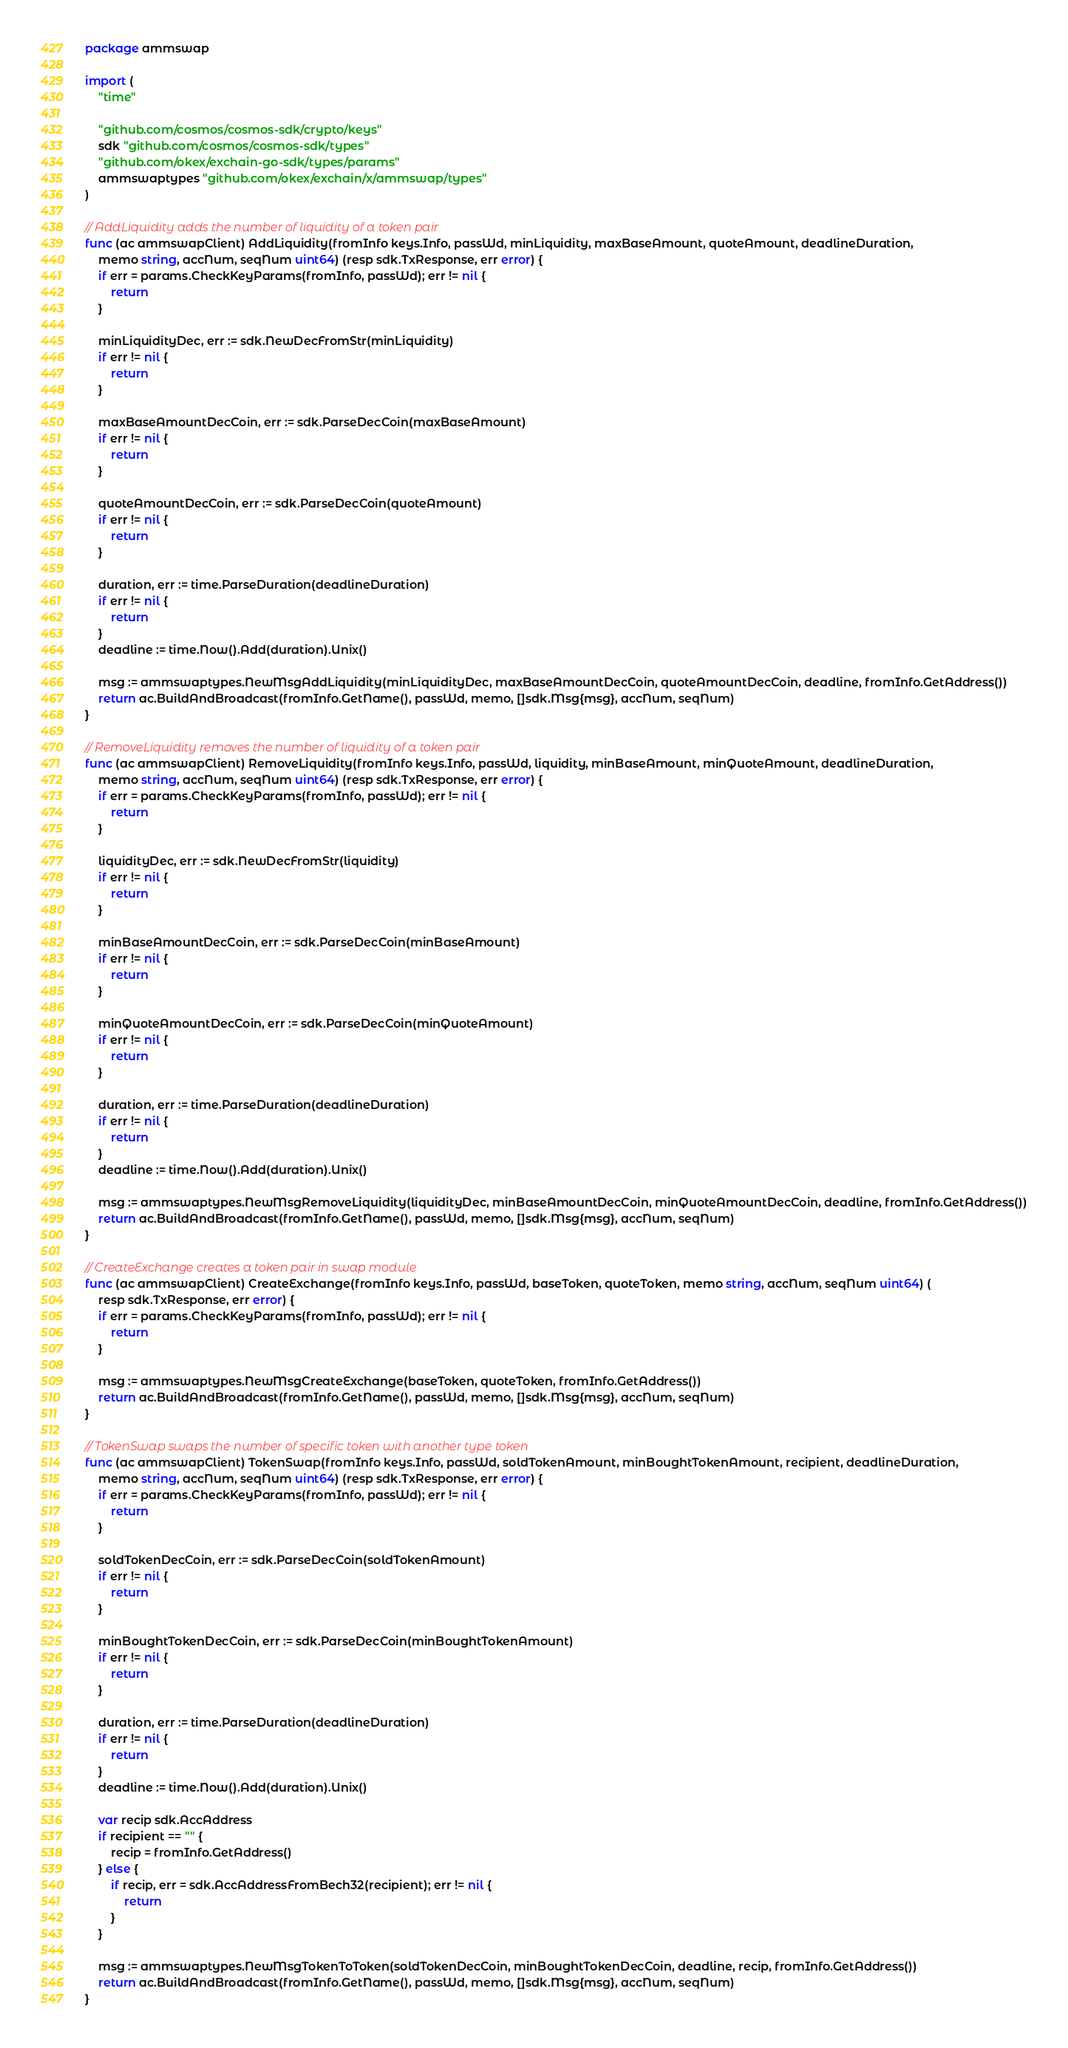<code> <loc_0><loc_0><loc_500><loc_500><_Go_>package ammswap

import (
	"time"

	"github.com/cosmos/cosmos-sdk/crypto/keys"
	sdk "github.com/cosmos/cosmos-sdk/types"
	"github.com/okex/exchain-go-sdk/types/params"
	ammswaptypes "github.com/okex/exchain/x/ammswap/types"
)

// AddLiquidity adds the number of liquidity of a token pair
func (ac ammswapClient) AddLiquidity(fromInfo keys.Info, passWd, minLiquidity, maxBaseAmount, quoteAmount, deadlineDuration,
	memo string, accNum, seqNum uint64) (resp sdk.TxResponse, err error) {
	if err = params.CheckKeyParams(fromInfo, passWd); err != nil {
		return
	}

	minLiquidityDec, err := sdk.NewDecFromStr(minLiquidity)
	if err != nil {
		return
	}

	maxBaseAmountDecCoin, err := sdk.ParseDecCoin(maxBaseAmount)
	if err != nil {
		return
	}

	quoteAmountDecCoin, err := sdk.ParseDecCoin(quoteAmount)
	if err != nil {
		return
	}

	duration, err := time.ParseDuration(deadlineDuration)
	if err != nil {
		return
	}
	deadline := time.Now().Add(duration).Unix()

	msg := ammswaptypes.NewMsgAddLiquidity(minLiquidityDec, maxBaseAmountDecCoin, quoteAmountDecCoin, deadline, fromInfo.GetAddress())
	return ac.BuildAndBroadcast(fromInfo.GetName(), passWd, memo, []sdk.Msg{msg}, accNum, seqNum)
}

// RemoveLiquidity removes the number of liquidity of a token pair
func (ac ammswapClient) RemoveLiquidity(fromInfo keys.Info, passWd, liquidity, minBaseAmount, minQuoteAmount, deadlineDuration,
	memo string, accNum, seqNum uint64) (resp sdk.TxResponse, err error) {
	if err = params.CheckKeyParams(fromInfo, passWd); err != nil {
		return
	}

	liquidityDec, err := sdk.NewDecFromStr(liquidity)
	if err != nil {
		return
	}

	minBaseAmountDecCoin, err := sdk.ParseDecCoin(minBaseAmount)
	if err != nil {
		return
	}

	minQuoteAmountDecCoin, err := sdk.ParseDecCoin(minQuoteAmount)
	if err != nil {
		return
	}

	duration, err := time.ParseDuration(deadlineDuration)
	if err != nil {
		return
	}
	deadline := time.Now().Add(duration).Unix()

	msg := ammswaptypes.NewMsgRemoveLiquidity(liquidityDec, minBaseAmountDecCoin, minQuoteAmountDecCoin, deadline, fromInfo.GetAddress())
	return ac.BuildAndBroadcast(fromInfo.GetName(), passWd, memo, []sdk.Msg{msg}, accNum, seqNum)
}

// CreateExchange creates a token pair in swap module
func (ac ammswapClient) CreateExchange(fromInfo keys.Info, passWd, baseToken, quoteToken, memo string, accNum, seqNum uint64) (
	resp sdk.TxResponse, err error) {
	if err = params.CheckKeyParams(fromInfo, passWd); err != nil {
		return
	}

	msg := ammswaptypes.NewMsgCreateExchange(baseToken, quoteToken, fromInfo.GetAddress())
	return ac.BuildAndBroadcast(fromInfo.GetName(), passWd, memo, []sdk.Msg{msg}, accNum, seqNum)
}

// TokenSwap swaps the number of specific token with another type token
func (ac ammswapClient) TokenSwap(fromInfo keys.Info, passWd, soldTokenAmount, minBoughtTokenAmount, recipient, deadlineDuration,
	memo string, accNum, seqNum uint64) (resp sdk.TxResponse, err error) {
	if err = params.CheckKeyParams(fromInfo, passWd); err != nil {
		return
	}

	soldTokenDecCoin, err := sdk.ParseDecCoin(soldTokenAmount)
	if err != nil {
		return
	}

	minBoughtTokenDecCoin, err := sdk.ParseDecCoin(minBoughtTokenAmount)
	if err != nil {
		return
	}

	duration, err := time.ParseDuration(deadlineDuration)
	if err != nil {
		return
	}
	deadline := time.Now().Add(duration).Unix()

	var recip sdk.AccAddress
	if recipient == "" {
		recip = fromInfo.GetAddress()
	} else {
		if recip, err = sdk.AccAddressFromBech32(recipient); err != nil {
			return
		}
	}

	msg := ammswaptypes.NewMsgTokenToToken(soldTokenDecCoin, minBoughtTokenDecCoin, deadline, recip, fromInfo.GetAddress())
	return ac.BuildAndBroadcast(fromInfo.GetName(), passWd, memo, []sdk.Msg{msg}, accNum, seqNum)
}
</code> 